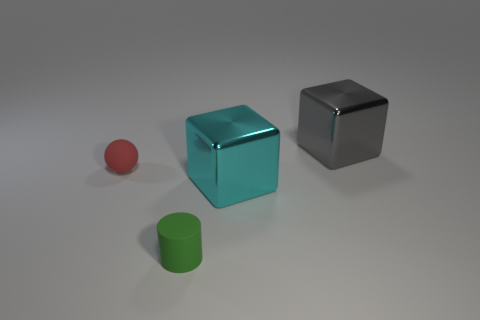Is the cyan metallic thing the same shape as the tiny green matte thing?
Ensure brevity in your answer.  No. What size is the cyan object that is the same shape as the large gray metal thing?
Offer a terse response. Large. How many cubes have the same material as the tiny sphere?
Your answer should be compact. 0. How many things are tiny matte objects or big cyan metal objects?
Provide a succinct answer. 3. There is a large shiny object that is behind the tiny red object; are there any large gray cubes that are to the left of it?
Provide a succinct answer. No. Is the number of metal blocks that are on the left side of the small sphere greater than the number of large gray things that are left of the large gray metallic thing?
Offer a terse response. No. What number of shiny cubes have the same color as the ball?
Give a very brief answer. 0. Is the color of the small thing in front of the ball the same as the metal block that is in front of the large gray shiny block?
Your response must be concise. No. There is a large cyan metallic block; are there any small green cylinders on the right side of it?
Keep it short and to the point. No. What is the big cyan thing made of?
Keep it short and to the point. Metal. 